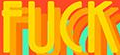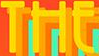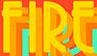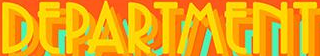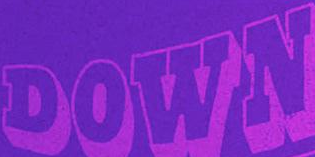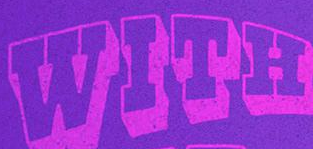Transcribe the words shown in these images in order, separated by a semicolon. FUCK; THE; FIRE; DEPARTMENT; DOWN; WITH 